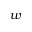Convert formula to latex. <formula><loc_0><loc_0><loc_500><loc_500>w</formula> 